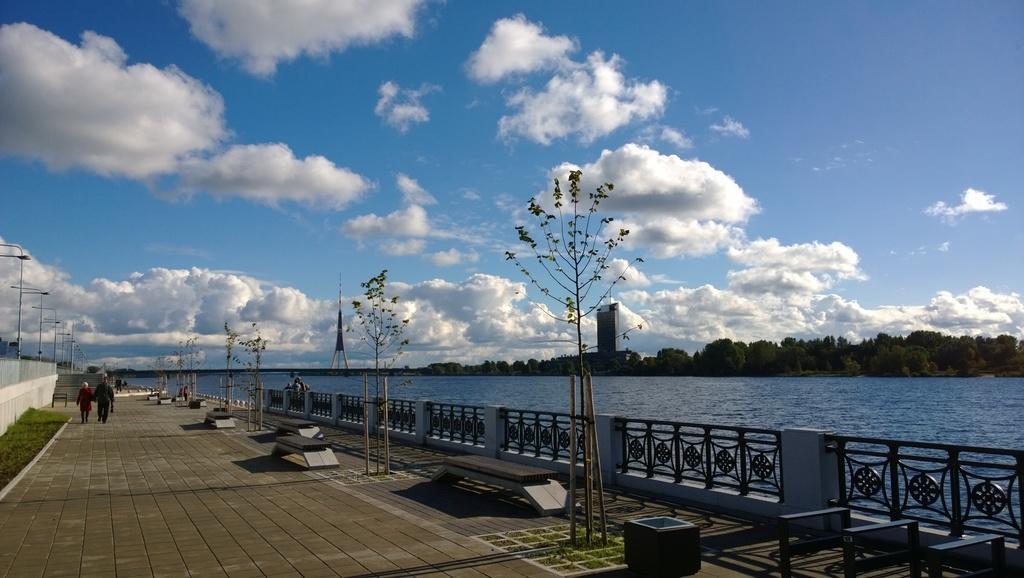Please provide a concise description of this image. In this image there are a few people walking on the path, there are few benches, trees, beside that there is a railing. On the left side of the image there is a railing, grass, street lights and in the background there is a river, trees, buildings and the sky. 